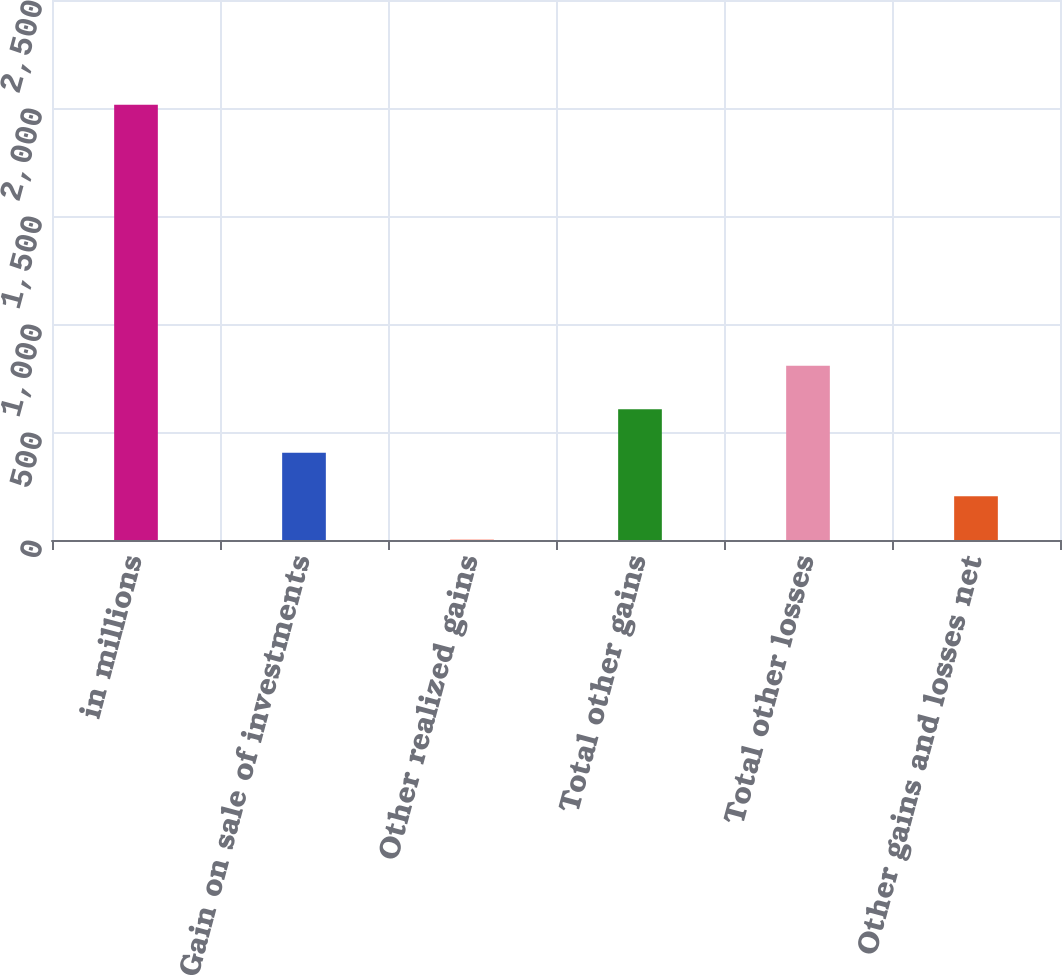Convert chart to OTSL. <chart><loc_0><loc_0><loc_500><loc_500><bar_chart><fcel>in millions<fcel>Gain on sale of investments<fcel>Other realized gains<fcel>Total other gains<fcel>Total other losses<fcel>Other gains and losses net<nl><fcel>2015<fcel>403.72<fcel>0.9<fcel>605.13<fcel>806.54<fcel>202.31<nl></chart> 